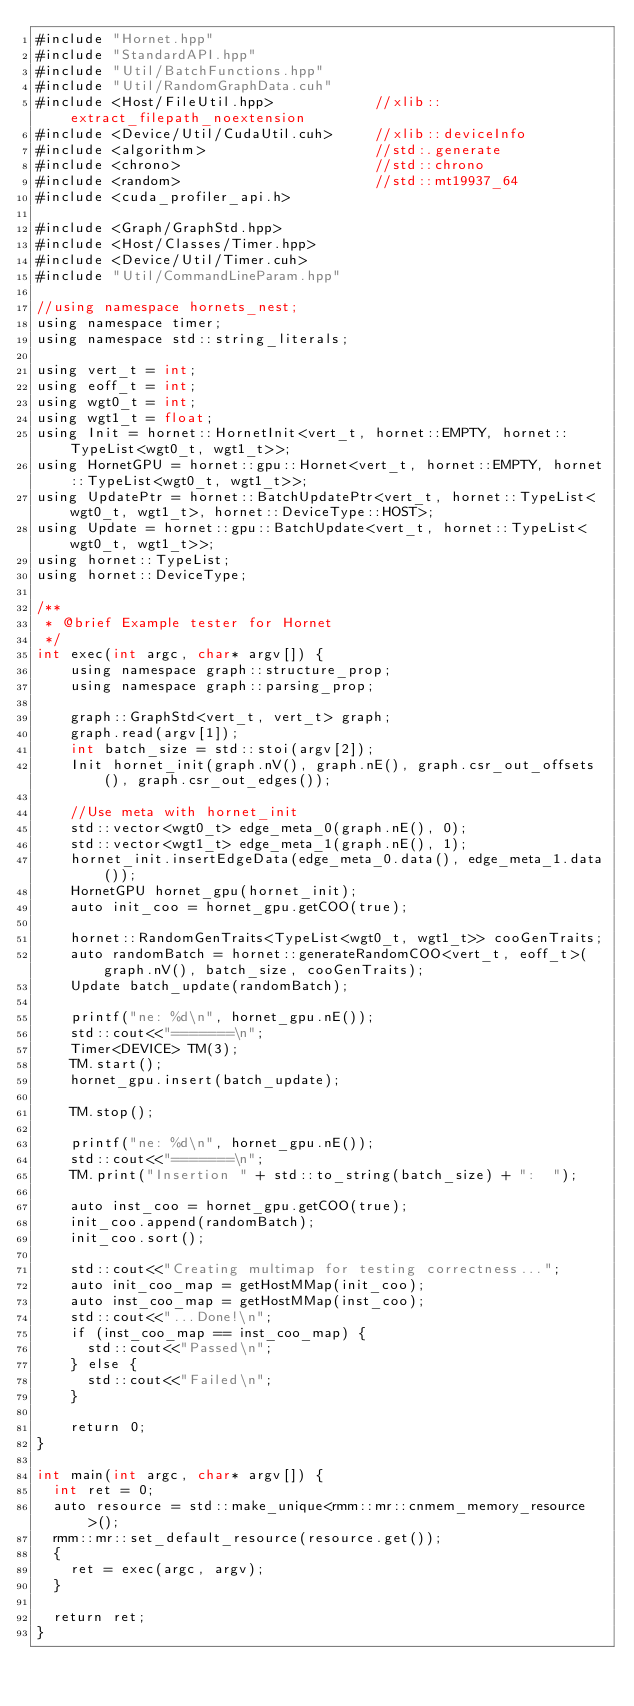<code> <loc_0><loc_0><loc_500><loc_500><_Cuda_>#include "Hornet.hpp"
#include "StandardAPI.hpp"
#include "Util/BatchFunctions.hpp"
#include "Util/RandomGraphData.cuh"
#include <Host/FileUtil.hpp>            //xlib::extract_filepath_noextension
#include <Device/Util/CudaUtil.cuh>     //xlib::deviceInfo
#include <algorithm>                    //std:.generate
#include <chrono>                       //std::chrono
#include <random>                       //std::mt19937_64
#include <cuda_profiler_api.h>

#include <Graph/GraphStd.hpp>
#include <Host/Classes/Timer.hpp>
#include <Device/Util/Timer.cuh>
#include "Util/CommandLineParam.hpp"

//using namespace hornets_nest;
using namespace timer;
using namespace std::string_literals;

using vert_t = int;
using eoff_t = int;
using wgt0_t = int;
using wgt1_t = float;
using Init = hornet::HornetInit<vert_t, hornet::EMPTY, hornet::TypeList<wgt0_t, wgt1_t>>;
using HornetGPU = hornet::gpu::Hornet<vert_t, hornet::EMPTY, hornet::TypeList<wgt0_t, wgt1_t>>;
using UpdatePtr = hornet::BatchUpdatePtr<vert_t, hornet::TypeList<wgt0_t, wgt1_t>, hornet::DeviceType::HOST>;
using Update = hornet::gpu::BatchUpdate<vert_t, hornet::TypeList<wgt0_t, wgt1_t>>;
using hornet::TypeList;
using hornet::DeviceType;

/**
 * @brief Example tester for Hornet
 */
int exec(int argc, char* argv[]) {
    using namespace graph::structure_prop;
    using namespace graph::parsing_prop;

    graph::GraphStd<vert_t, vert_t> graph;
    graph.read(argv[1]);
    int batch_size = std::stoi(argv[2]);
    Init hornet_init(graph.nV(), graph.nE(), graph.csr_out_offsets(), graph.csr_out_edges());

    //Use meta with hornet_init
    std::vector<wgt0_t> edge_meta_0(graph.nE(), 0);
    std::vector<wgt1_t> edge_meta_1(graph.nE(), 1);
    hornet_init.insertEdgeData(edge_meta_0.data(), edge_meta_1.data());
    HornetGPU hornet_gpu(hornet_init);
    auto init_coo = hornet_gpu.getCOO(true);

    hornet::RandomGenTraits<TypeList<wgt0_t, wgt1_t>> cooGenTraits;
    auto randomBatch = hornet::generateRandomCOO<vert_t, eoff_t>(graph.nV(), batch_size, cooGenTraits);
    Update batch_update(randomBatch);

    printf("ne: %d\n", hornet_gpu.nE());
    std::cout<<"=======\n";
    Timer<DEVICE> TM(3);
    TM.start();
    hornet_gpu.insert(batch_update);

    TM.stop();

    printf("ne: %d\n", hornet_gpu.nE());
    std::cout<<"=======\n";
    TM.print("Insertion " + std::to_string(batch_size) + ":  ");

    auto inst_coo = hornet_gpu.getCOO(true);
    init_coo.append(randomBatch);
    init_coo.sort();

    std::cout<<"Creating multimap for testing correctness...";
    auto init_coo_map = getHostMMap(init_coo);
    auto inst_coo_map = getHostMMap(inst_coo);
    std::cout<<"...Done!\n";
    if (inst_coo_map == inst_coo_map) {
      std::cout<<"Passed\n";
    } else {
      std::cout<<"Failed\n";
    }

    return 0;
}

int main(int argc, char* argv[]) {
  int ret = 0;
  auto resource = std::make_unique<rmm::mr::cnmem_memory_resource>();
  rmm::mr::set_default_resource(resource.get());
  {
    ret = exec(argc, argv);
  }

  return ret;
}

</code> 